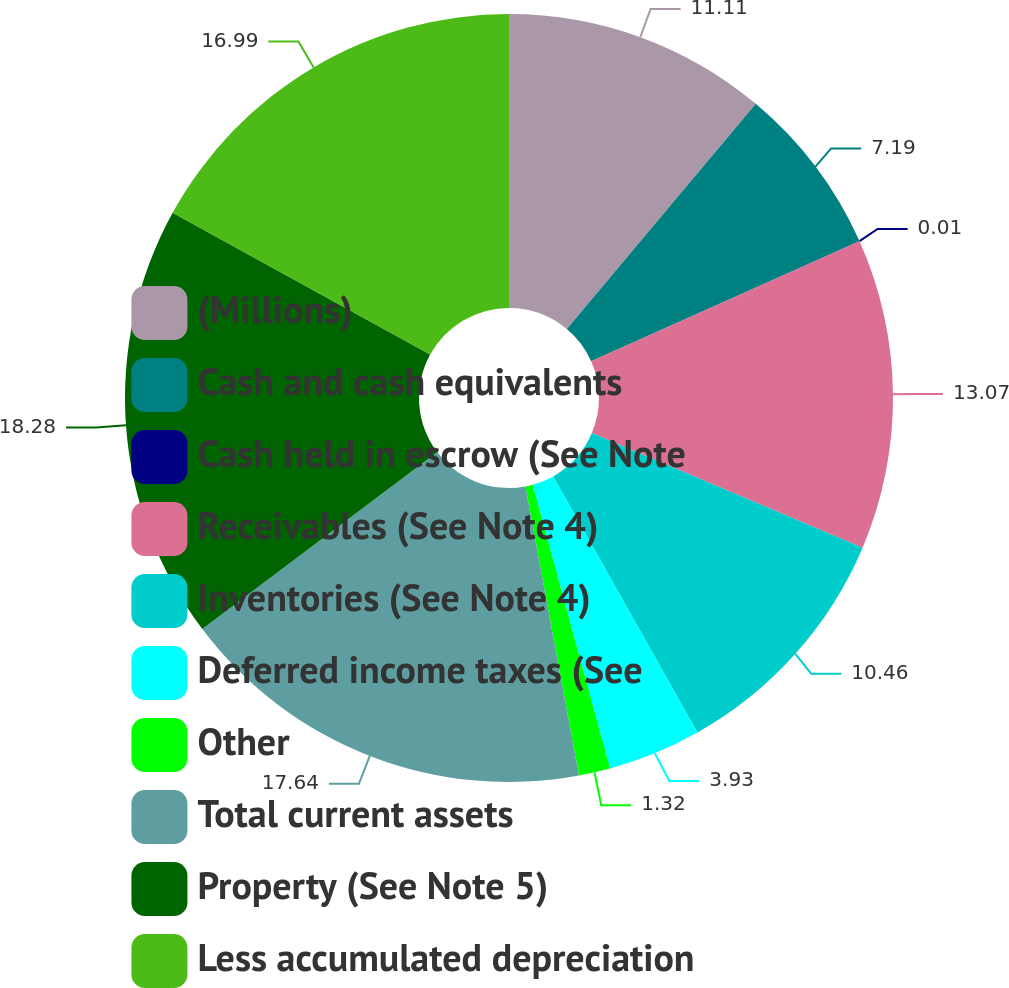<chart> <loc_0><loc_0><loc_500><loc_500><pie_chart><fcel>(Millions)<fcel>Cash and cash equivalents<fcel>Cash held in escrow (See Note<fcel>Receivables (See Note 4)<fcel>Inventories (See Note 4)<fcel>Deferred income taxes (See<fcel>Other<fcel>Total current assets<fcel>Property (See Note 5)<fcel>Less accumulated depreciation<nl><fcel>11.11%<fcel>7.19%<fcel>0.01%<fcel>13.07%<fcel>10.46%<fcel>3.93%<fcel>1.32%<fcel>17.64%<fcel>18.29%<fcel>16.99%<nl></chart> 